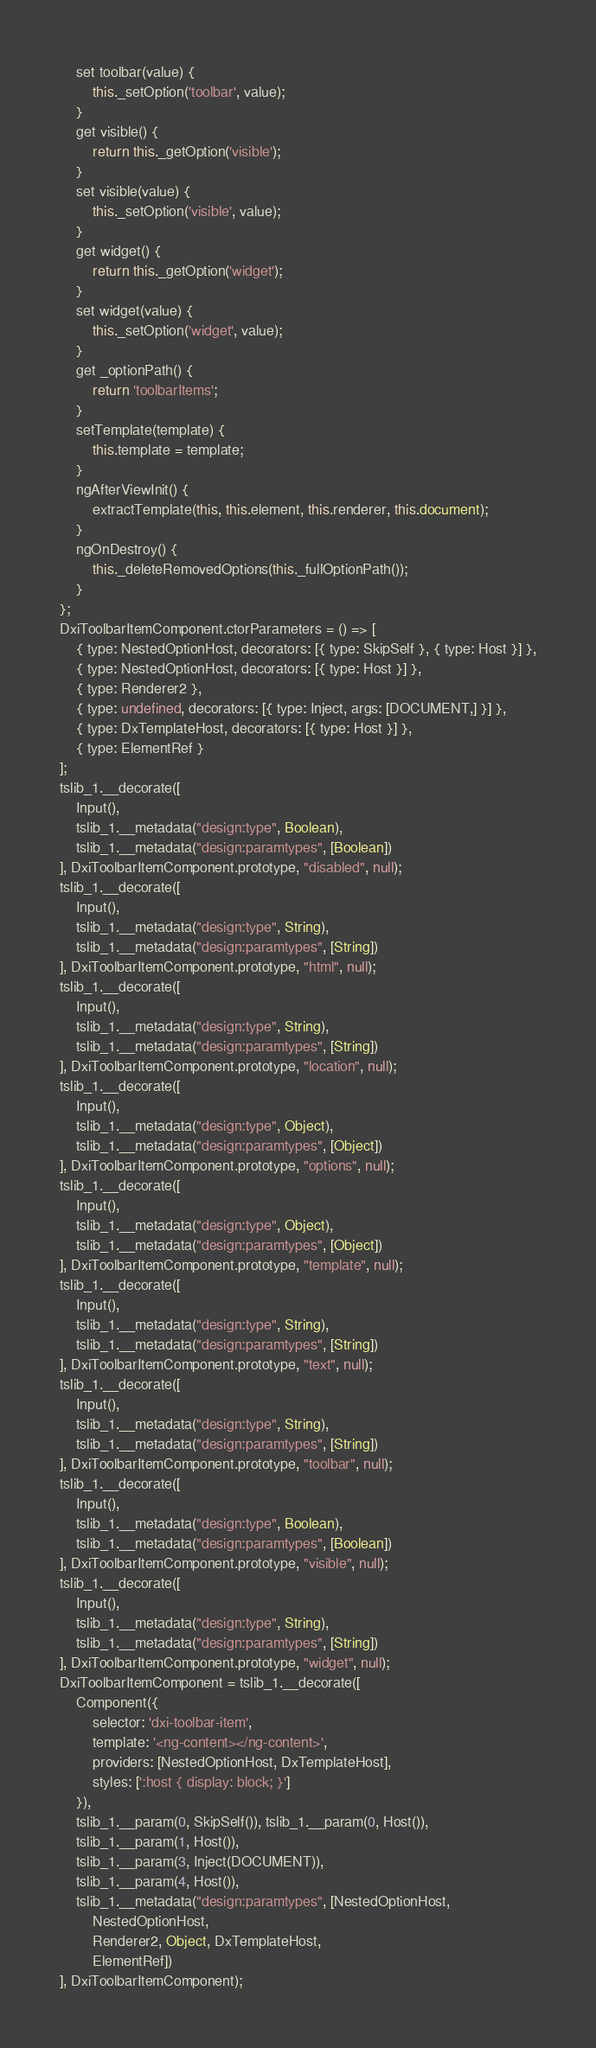Convert code to text. <code><loc_0><loc_0><loc_500><loc_500><_JavaScript_>    set toolbar(value) {
        this._setOption('toolbar', value);
    }
    get visible() {
        return this._getOption('visible');
    }
    set visible(value) {
        this._setOption('visible', value);
    }
    get widget() {
        return this._getOption('widget');
    }
    set widget(value) {
        this._setOption('widget', value);
    }
    get _optionPath() {
        return 'toolbarItems';
    }
    setTemplate(template) {
        this.template = template;
    }
    ngAfterViewInit() {
        extractTemplate(this, this.element, this.renderer, this.document);
    }
    ngOnDestroy() {
        this._deleteRemovedOptions(this._fullOptionPath());
    }
};
DxiToolbarItemComponent.ctorParameters = () => [
    { type: NestedOptionHost, decorators: [{ type: SkipSelf }, { type: Host }] },
    { type: NestedOptionHost, decorators: [{ type: Host }] },
    { type: Renderer2 },
    { type: undefined, decorators: [{ type: Inject, args: [DOCUMENT,] }] },
    { type: DxTemplateHost, decorators: [{ type: Host }] },
    { type: ElementRef }
];
tslib_1.__decorate([
    Input(),
    tslib_1.__metadata("design:type", Boolean),
    tslib_1.__metadata("design:paramtypes", [Boolean])
], DxiToolbarItemComponent.prototype, "disabled", null);
tslib_1.__decorate([
    Input(),
    tslib_1.__metadata("design:type", String),
    tslib_1.__metadata("design:paramtypes", [String])
], DxiToolbarItemComponent.prototype, "html", null);
tslib_1.__decorate([
    Input(),
    tslib_1.__metadata("design:type", String),
    tslib_1.__metadata("design:paramtypes", [String])
], DxiToolbarItemComponent.prototype, "location", null);
tslib_1.__decorate([
    Input(),
    tslib_1.__metadata("design:type", Object),
    tslib_1.__metadata("design:paramtypes", [Object])
], DxiToolbarItemComponent.prototype, "options", null);
tslib_1.__decorate([
    Input(),
    tslib_1.__metadata("design:type", Object),
    tslib_1.__metadata("design:paramtypes", [Object])
], DxiToolbarItemComponent.prototype, "template", null);
tslib_1.__decorate([
    Input(),
    tslib_1.__metadata("design:type", String),
    tslib_1.__metadata("design:paramtypes", [String])
], DxiToolbarItemComponent.prototype, "text", null);
tslib_1.__decorate([
    Input(),
    tslib_1.__metadata("design:type", String),
    tslib_1.__metadata("design:paramtypes", [String])
], DxiToolbarItemComponent.prototype, "toolbar", null);
tslib_1.__decorate([
    Input(),
    tslib_1.__metadata("design:type", Boolean),
    tslib_1.__metadata("design:paramtypes", [Boolean])
], DxiToolbarItemComponent.prototype, "visible", null);
tslib_1.__decorate([
    Input(),
    tslib_1.__metadata("design:type", String),
    tslib_1.__metadata("design:paramtypes", [String])
], DxiToolbarItemComponent.prototype, "widget", null);
DxiToolbarItemComponent = tslib_1.__decorate([
    Component({
        selector: 'dxi-toolbar-item',
        template: '<ng-content></ng-content>',
        providers: [NestedOptionHost, DxTemplateHost],
        styles: [':host { display: block; }']
    }),
    tslib_1.__param(0, SkipSelf()), tslib_1.__param(0, Host()),
    tslib_1.__param(1, Host()),
    tslib_1.__param(3, Inject(DOCUMENT)),
    tslib_1.__param(4, Host()),
    tslib_1.__metadata("design:paramtypes", [NestedOptionHost,
        NestedOptionHost,
        Renderer2, Object, DxTemplateHost,
        ElementRef])
], DxiToolbarItemComponent);</code> 